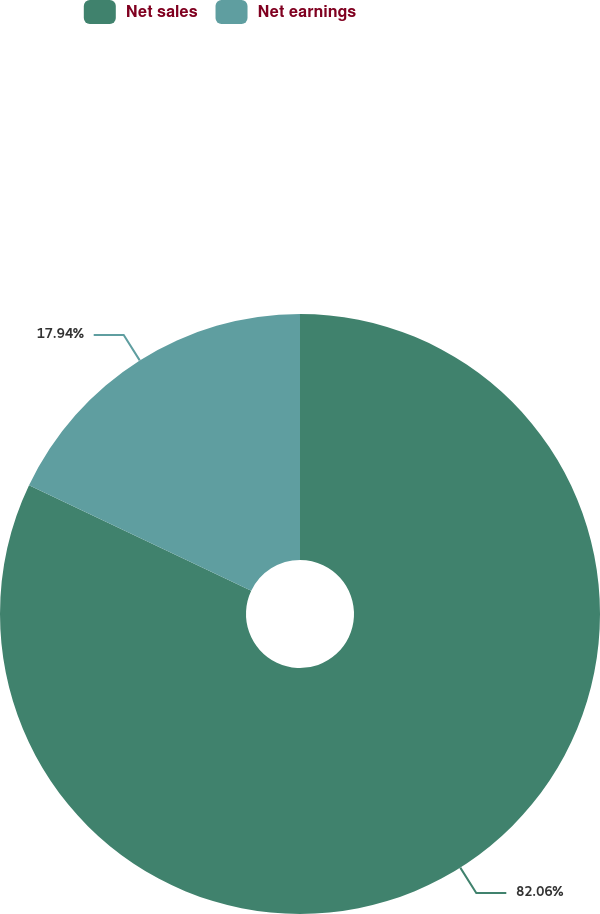Convert chart to OTSL. <chart><loc_0><loc_0><loc_500><loc_500><pie_chart><fcel>Net sales<fcel>Net earnings<nl><fcel>82.06%<fcel>17.94%<nl></chart> 